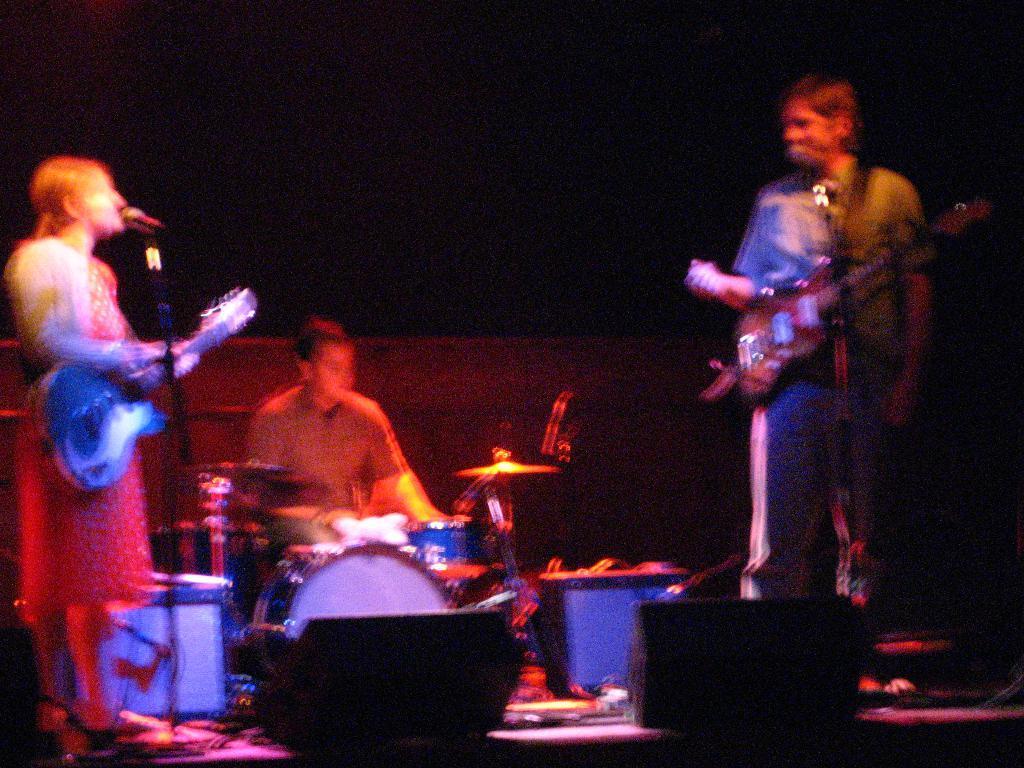How would you summarize this image in a sentence or two? In this picture we can see three persons playing musical instruments such as guitar, drums and singing on mic and in background it is dark. 